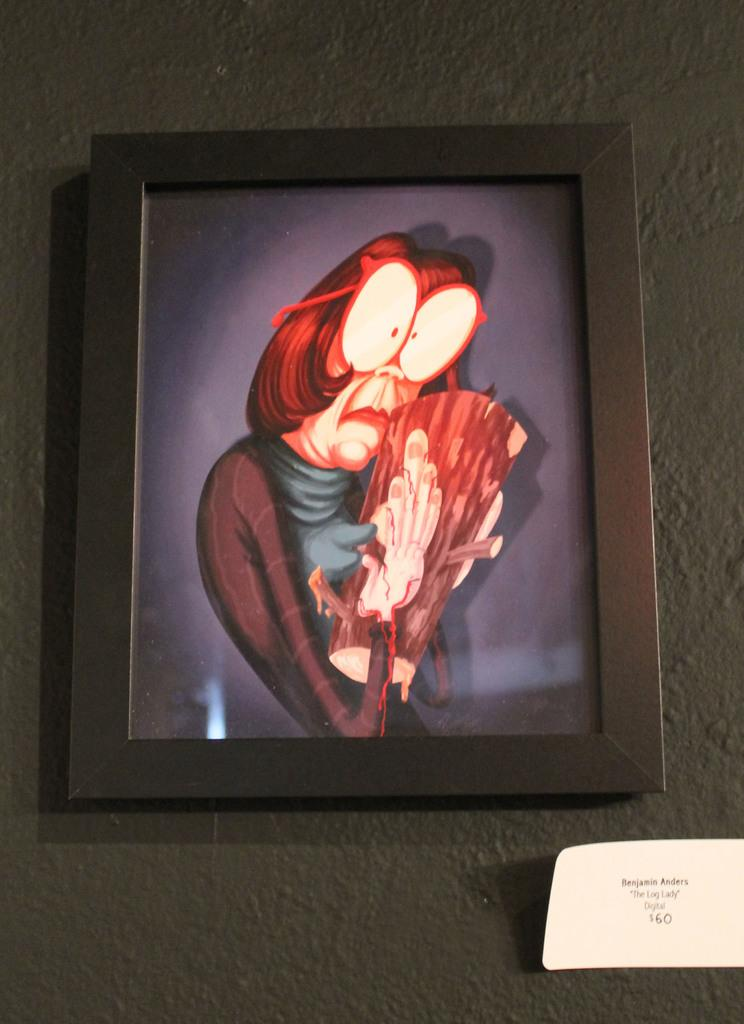What can be seen on the wall in the image? There is a photo frame on the wall in the image. What is hanging on the wall in the image? There is a photo frame on the wall. What type of hand is holding the locket in the image? There is no hand or locket present in the image; it only features a wall with a photo frame. 